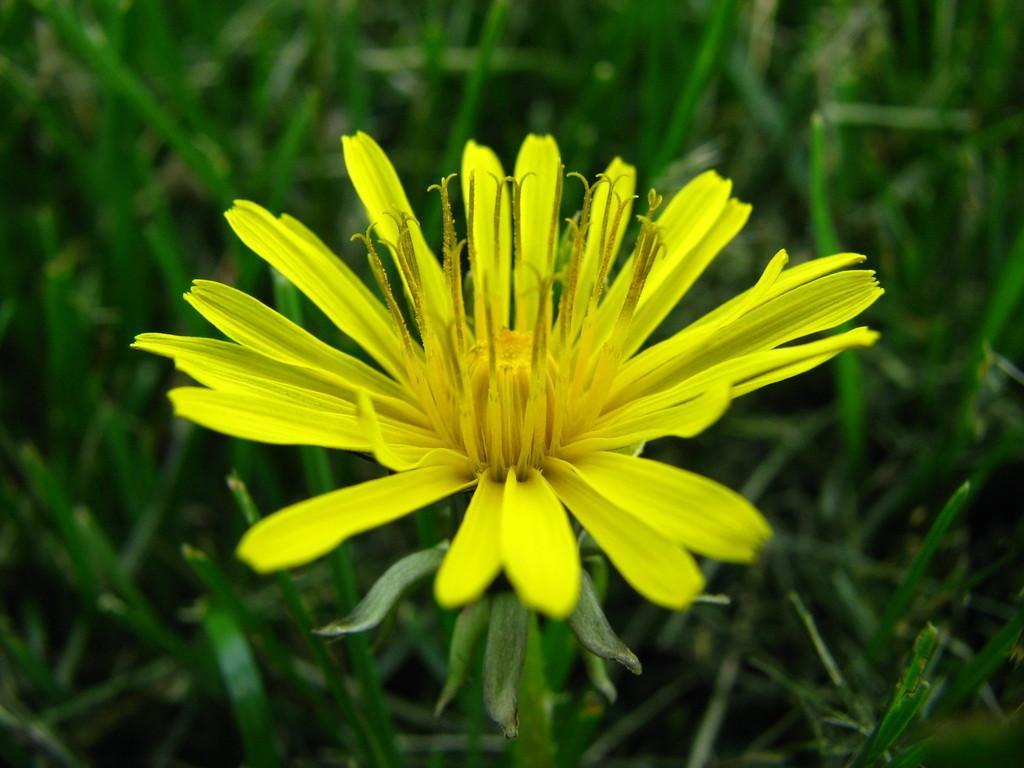Please provide a concise description of this image. There is a plant having yellow color flower. In the background, there are other plants which are having green color leaves. 